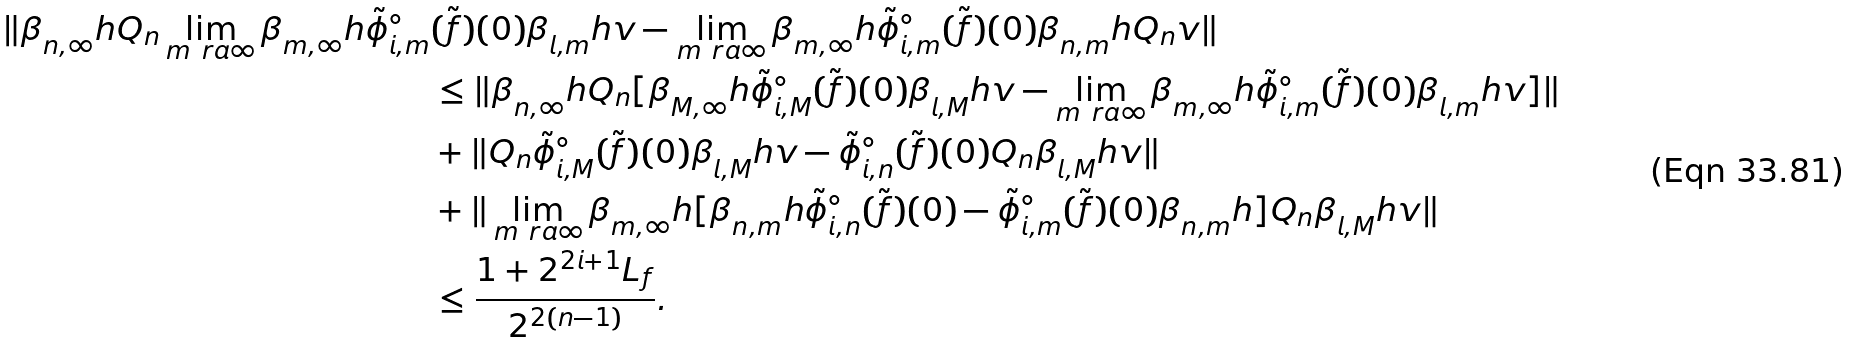<formula> <loc_0><loc_0><loc_500><loc_500>\| \beta _ { n , \infty } ^ { \ } h Q _ { n } \lim _ { m \ r a \infty } \beta _ { m , \infty } ^ { \ } h \tilde { \phi } ^ { \circ } _ { i , m } & ( \tilde { f } ) ( 0 ) \beta _ { l , m } ^ { \ } h v - \lim _ { m \ r a \infty } \beta _ { m , \infty } ^ { \ } h \tilde { \phi } ^ { \circ } _ { i , m } ( \tilde { f } ) ( 0 ) \beta _ { n , m } ^ { \ } h Q _ { n } v \| \\ & \leq \| \beta _ { n , \infty } ^ { \ } h Q _ { n } [ \beta _ { M , \infty } ^ { \ } h \tilde { \phi } ^ { \circ } _ { i , M } ( \tilde { f } ) ( 0 ) \beta _ { l , M } ^ { \ } h v - \lim _ { m \ r a \infty } \beta _ { m , \infty } ^ { \ } h \tilde { \phi } ^ { \circ } _ { i , m } ( \tilde { f } ) ( 0 ) \beta _ { l , m } ^ { \ } h v ] \| \\ & + \| Q _ { n } \tilde { \phi } ^ { \circ } _ { i , M } ( \tilde { f } ) ( 0 ) \beta _ { l , M } ^ { \ } h v - \tilde { \phi } ^ { \circ } _ { i , n } ( \tilde { f } ) ( 0 ) Q _ { n } \beta _ { l , M } ^ { \ } h v \| \\ & + \| \lim _ { m \ r a \infty } \beta _ { m , \infty } ^ { \ } h [ \beta _ { n , m } ^ { \ } h \tilde { \phi } ^ { \circ } _ { i , n } ( \tilde { f } ) ( 0 ) - \tilde { \phi } ^ { \circ } _ { i , m } ( \tilde { f } ) ( 0 ) \beta _ { n , m } ^ { \ } h ] Q _ { n } \beta _ { l , M } ^ { \ } h v \| \\ & \leq \frac { 1 + 2 ^ { 2 i + 1 } L _ { f } } { 2 ^ { 2 ( n - 1 ) } } .</formula> 